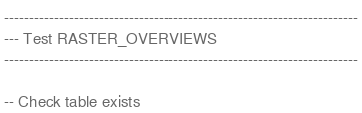<code> <loc_0><loc_0><loc_500><loc_500><_SQL_>
-----------------------------------------------------------------------
--- Test RASTER_OVERVIEWS
-----------------------------------------------------------------------

-- Check table exists</code> 